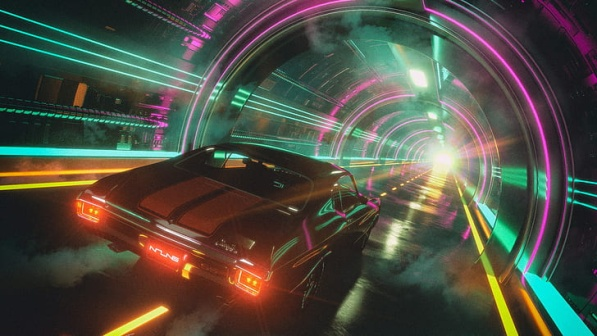Can you describe the car in more detail? Absolutely! The car in the image is a sleek, black sports car, likely a futuristic model based on its design and features. It has a low, aerodynamic profile, emphasizing speed and performance. The rear of the car is adorned with two horizontal red taillights that extend almost the entire width of the vehicle, contributing to its modern look. The car’s body is smooth and streamlined, with sharp angles and curves that enhance its aggressive appearance. The windows are tinted, adding to the car’s mysterious and stylish aura. Overall, its design speaks volumes about both its speed and sophistication. Why do you think the lights inside the tunnel are so vibrant and colorful? The vibrant and colorful lights inside the tunnel likely serve multiple purposes. Firstly, they enhance the futuristic and high-tech atmosphere of the scene, suggesting advanced technology and modernity. Secondly, the bright and contrasting neon colors might be used to improve visibility and orientation within the tunnel, ensuring that drivers can easily navigate through it. Lastly, the dramatic lighting adds a sense of excitement and dynamism to the image, making the journey through the tunnel feel more thrilling and immersive. 